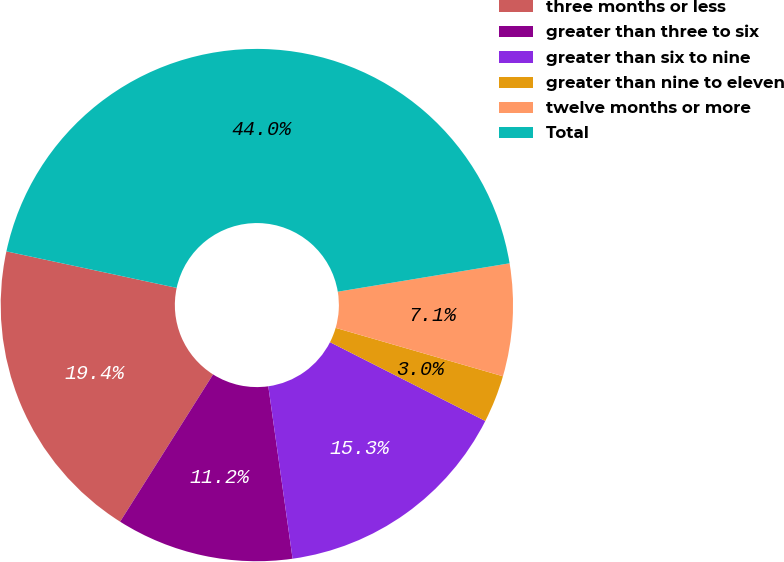Convert chart. <chart><loc_0><loc_0><loc_500><loc_500><pie_chart><fcel>three months or less<fcel>greater than three to six<fcel>greater than six to nine<fcel>greater than nine to eleven<fcel>twelve months or more<fcel>Total<nl><fcel>19.4%<fcel>11.19%<fcel>15.3%<fcel>2.99%<fcel>7.09%<fcel>44.03%<nl></chart> 